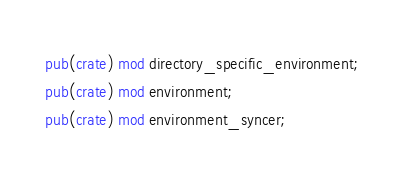Convert code to text. <code><loc_0><loc_0><loc_500><loc_500><_Rust_>pub(crate) mod directory_specific_environment;
pub(crate) mod environment;
pub(crate) mod environment_syncer;
</code> 